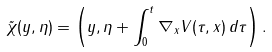<formula> <loc_0><loc_0><loc_500><loc_500>\tilde { \chi } ( y , \eta ) = \left ( y , \eta + \int _ { 0 } ^ { t } \nabla _ { x } V ( \tau , x ) \, d \tau \right ) .</formula> 